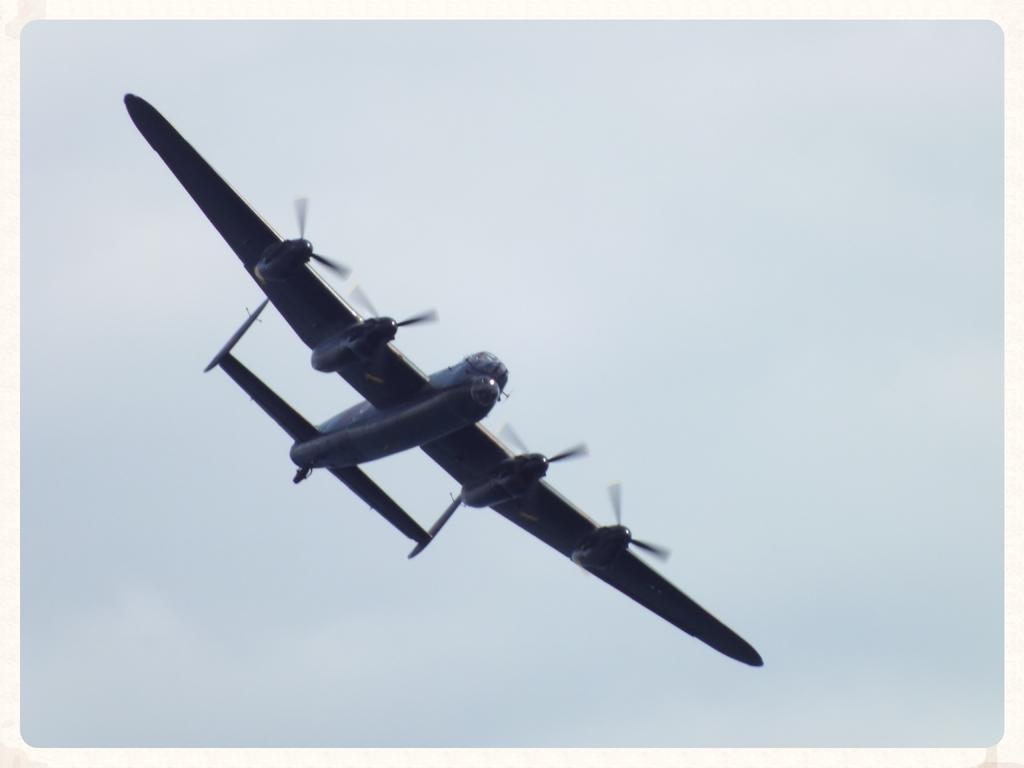What is the main subject of the image? The main subject of the image is an aircraft flying. What can be seen in the background of the image? The sky is visible at the top of the image. Can you describe the nature of the image? The image is an edited picture. How many cakes are being blown out in the image? There are no cakes or blowing out of candles present in the image; it features an aircraft flying in the sky. 